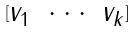<formula> <loc_0><loc_0><loc_500><loc_500>[ \begin{matrix} v _ { 1 } & \cdot \cdot \cdot & v _ { k } \end{matrix} ]</formula> 